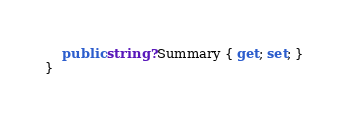Convert code to text. <code><loc_0><loc_0><loc_500><loc_500><_C#_>
    public string? Summary { get; set; }
}
</code> 